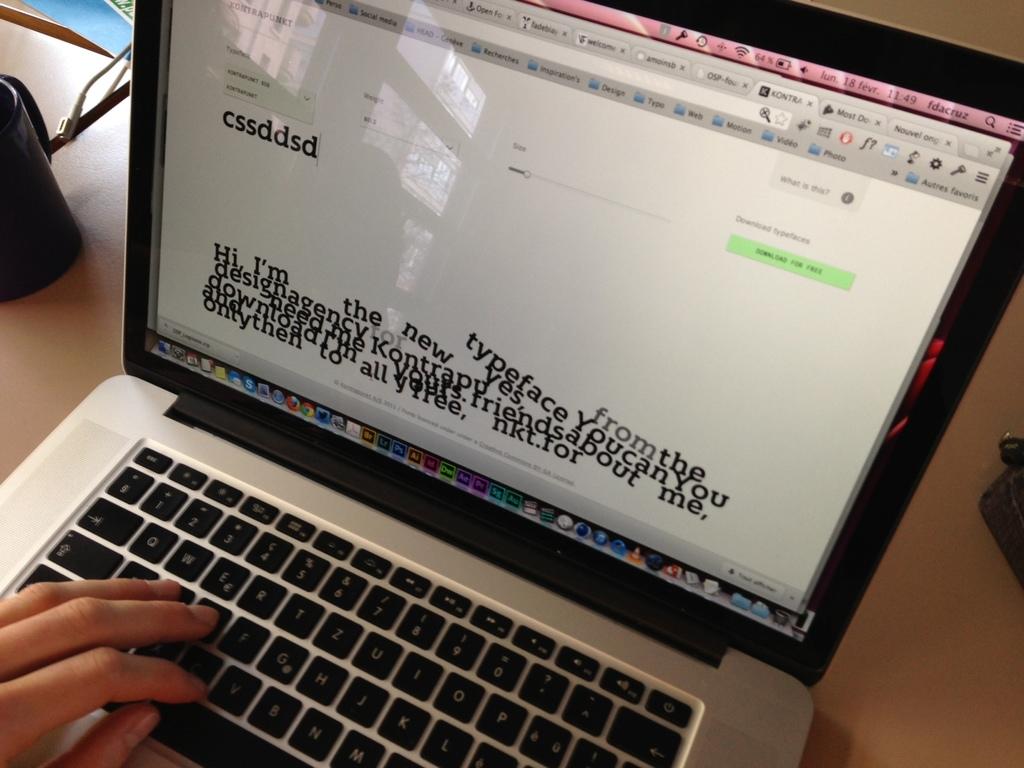What time is it on this laptop?
Provide a short and direct response. 11:49. 